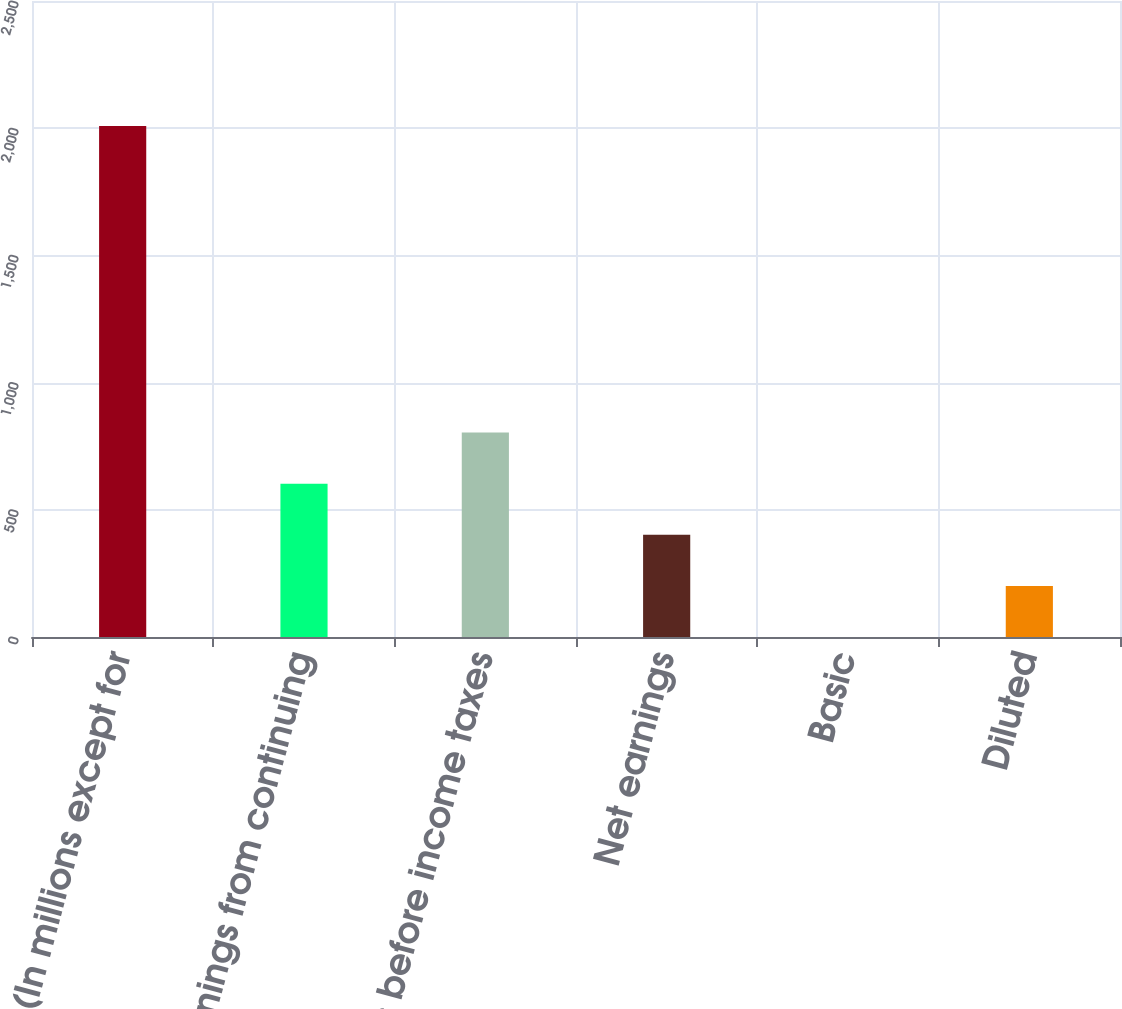Convert chart to OTSL. <chart><loc_0><loc_0><loc_500><loc_500><bar_chart><fcel>(In millions except for<fcel>Earnings from continuing<fcel>Earnings before income taxes<fcel>Net earnings<fcel>Basic<fcel>Diluted<nl><fcel>2009<fcel>602.73<fcel>803.62<fcel>401.84<fcel>0.06<fcel>200.95<nl></chart> 